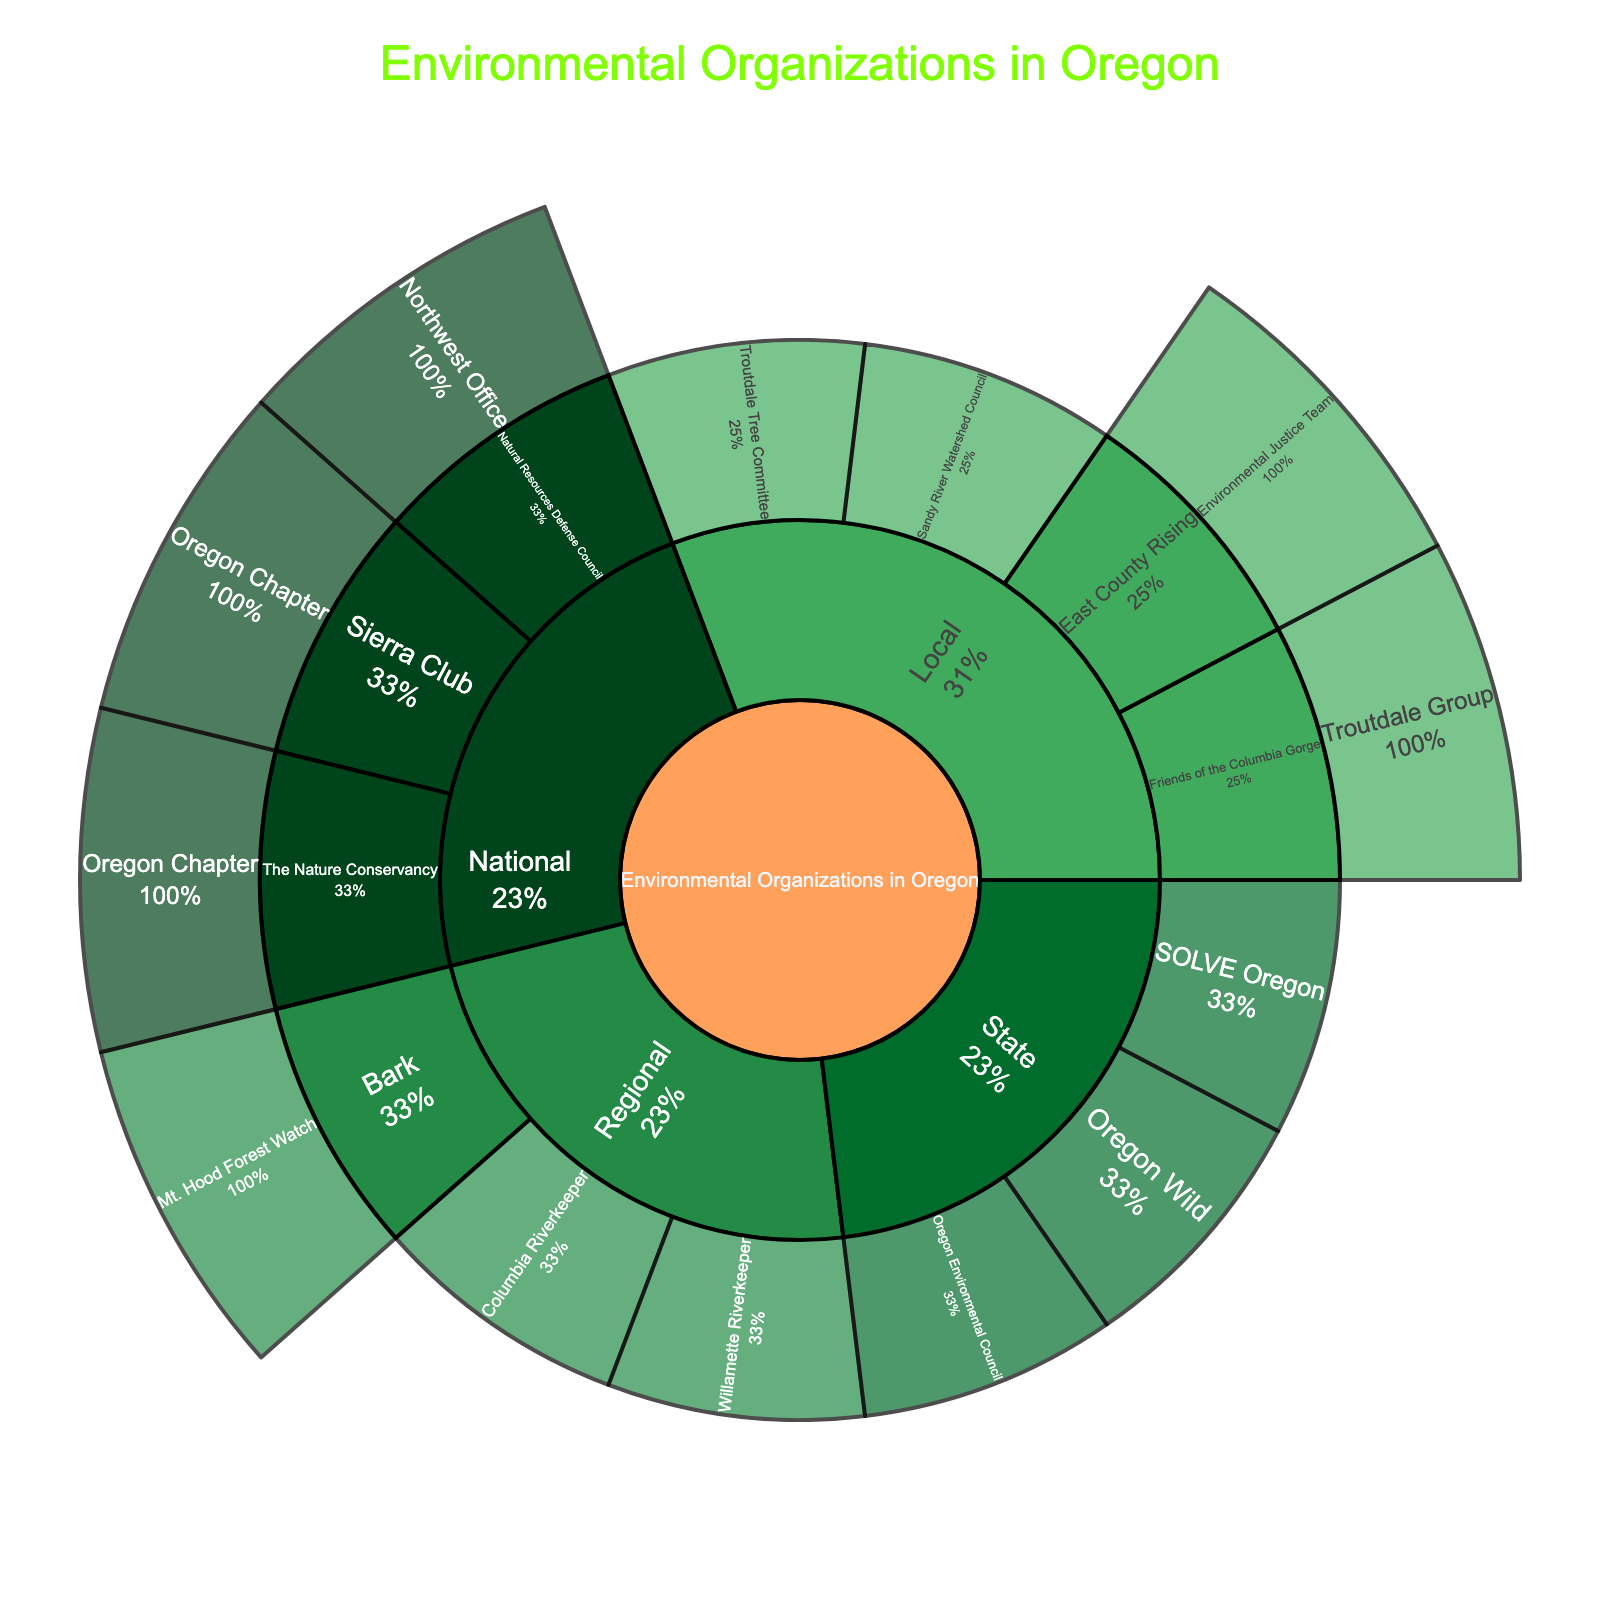what is the title of the sunburst plot? The title of the sunburst plot is usually located at the top of the figure and is the largest text fontwise. By looking at the figure, we can see the title.
Answer: Environmental Organizations in Oregon How many main levels (excluding the root) does the sunburst plot have? The main levels can be identified by looking at the hierarchy of the branches in the sunburst plot. Each concentric circle typically represents a different level. By counting the circles, we can determine the number of levels.
Answer: 3 Which organizations belong to the 'National' category in the plot? We can identify the 'National' category by looking at the first level branches under 'Environmental Organizations in Oregon'. The sub-branches under 'National' will provide the information about the specific organizations.
Answer: Sierra Club, Natural Resources Defense Council, The Nature Conservancy What is the percentage of 'State' organizations compared to all other levels? To determine this, we locate the 'State' section and check its size relative to the whole sunburst. Since labels include percentage information, we can ascertain this directly.
Answer: Specific percentage from the figure Which 'Local' organization is specific to Troutdale? We can identify the organization specific to Troutdale by looking under the 'Local' branch and finding any organizations that contain 'Troutdale' within their label.
Answer: Friends of the Columbia Gorge, Troutdale Group How many organizations are listed under the 'Regional' level? By examining the 'Regional' section, we count each unique branch to determine the number of listed organizations.
Answer: 3 Which level has the most organizations listed? This can be determined by counting the number of branches at each level and comparing them to find the level with the highest count.
Answer: Local What is common between the organizations at the 'State' level? To answer this, examine the organizations under the 'State' section and identify common attributes they share, such as the type of work they do or the areas they focus on.
Answer: They operate specifically at the state level in Oregon Which organization under 'National' has a regional office titled 'Northwest Office'? Look under the 'National' section and identify which organization has a sub-branch named 'Northwest Office'.
Answer: Natural Resources Defense Council For the 'Local' organizations, which one has an 'Environmental Justice Team'? By checking the subcategories under the 'Local' section, we find which organization includes an 'Environmental Justice Team'.
Answer: East County Rising Does 'Oregon Wild' belong to the 'State' or 'Regional' level? Check under the 'State' and 'Regional' categories to see where 'Oregon Wild' is listed.
Answer: State 